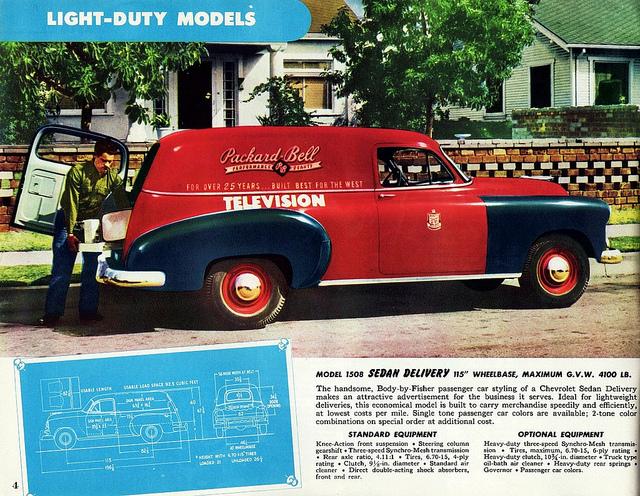Is this a delivery being made?
Write a very short answer. Yes. How many people can be seen?
Concise answer only. 1. What do the people who drive the van sell?
Keep it brief. Televisions. 